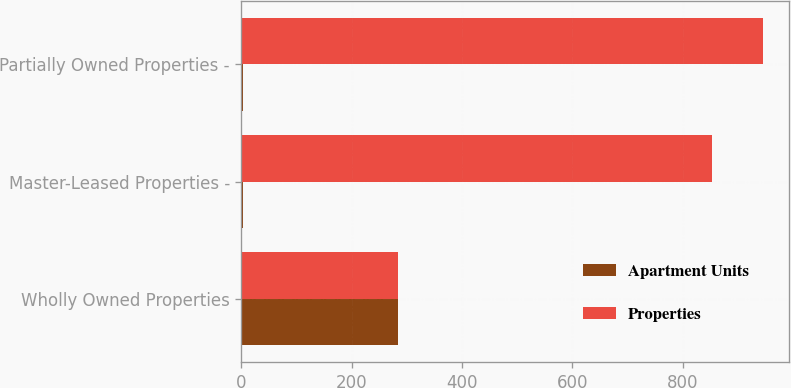Convert chart to OTSL. <chart><loc_0><loc_0><loc_500><loc_500><stacked_bar_chart><ecel><fcel>Wholly Owned Properties<fcel>Master-Leased Properties -<fcel>Partially Owned Properties -<nl><fcel>Apartment Units<fcel>283<fcel>3<fcel>2<nl><fcel>Properties<fcel>283<fcel>853<fcel>945<nl></chart> 